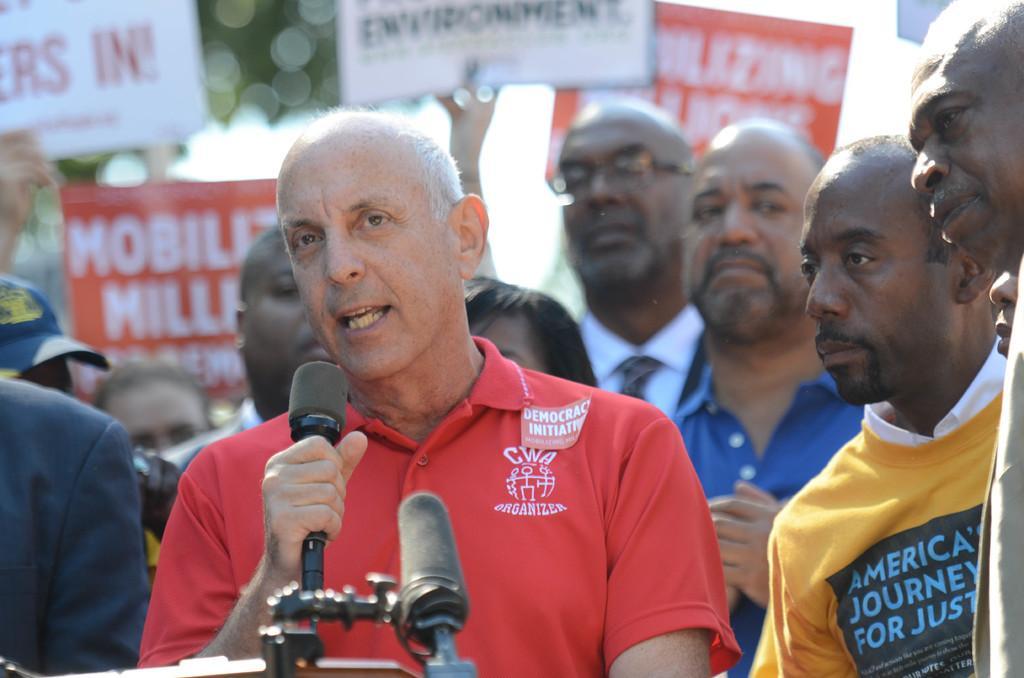Could you give a brief overview of what you see in this image? Here in this picture we can see a group of men standing over a place and in the middle we can see a person speaking something in the microphones present in front of him and we can see some people are wearing placards and protesting. 